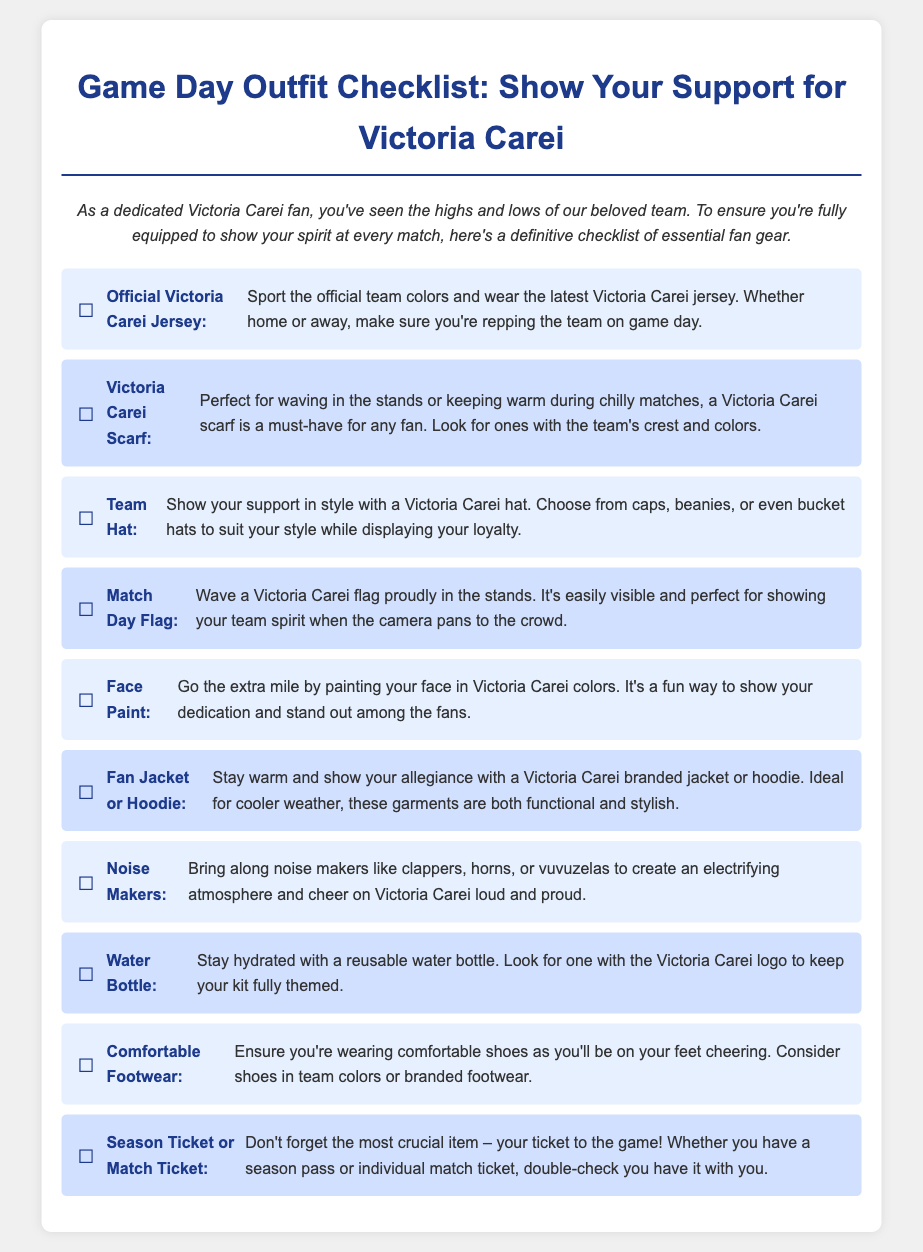What is the title of the checklist? The title of the checklist is prominently displayed at the top of the document.
Answer: Game Day Outfit Checklist: Show Your Support for Victoria Carei How many items are in the checklist? The document lists a total of the essential fan gear items for game day.
Answer: 10 What is one type of item listed for showing support? The checklist includes various items that fans can wear or bring to support their team.
Answer: Official Victoria Carei Jersey What is suggested for staying warm during matches? Among the items, there is one specifically recommended for warmth during colder matches.
Answer: Fan Jacket or Hoodie What should you bring for hydration? The checklist specifies an item needed to stay hydrated while cheering for the team.
Answer: Water Bottle Which item is used for creating noise at games? The document mentions an item that enhances the atmosphere during matches.
Answer: Noise Makers What is the purpose of face paint? The checklist describes face paint as a way to visually demonstrate support for the team.
Answer: Show your dedication What is the last item listed in the checklist? The order of items in the checklist culminates with a crucial requirement for attending a game.
Answer: Season Ticket or Match Ticket 